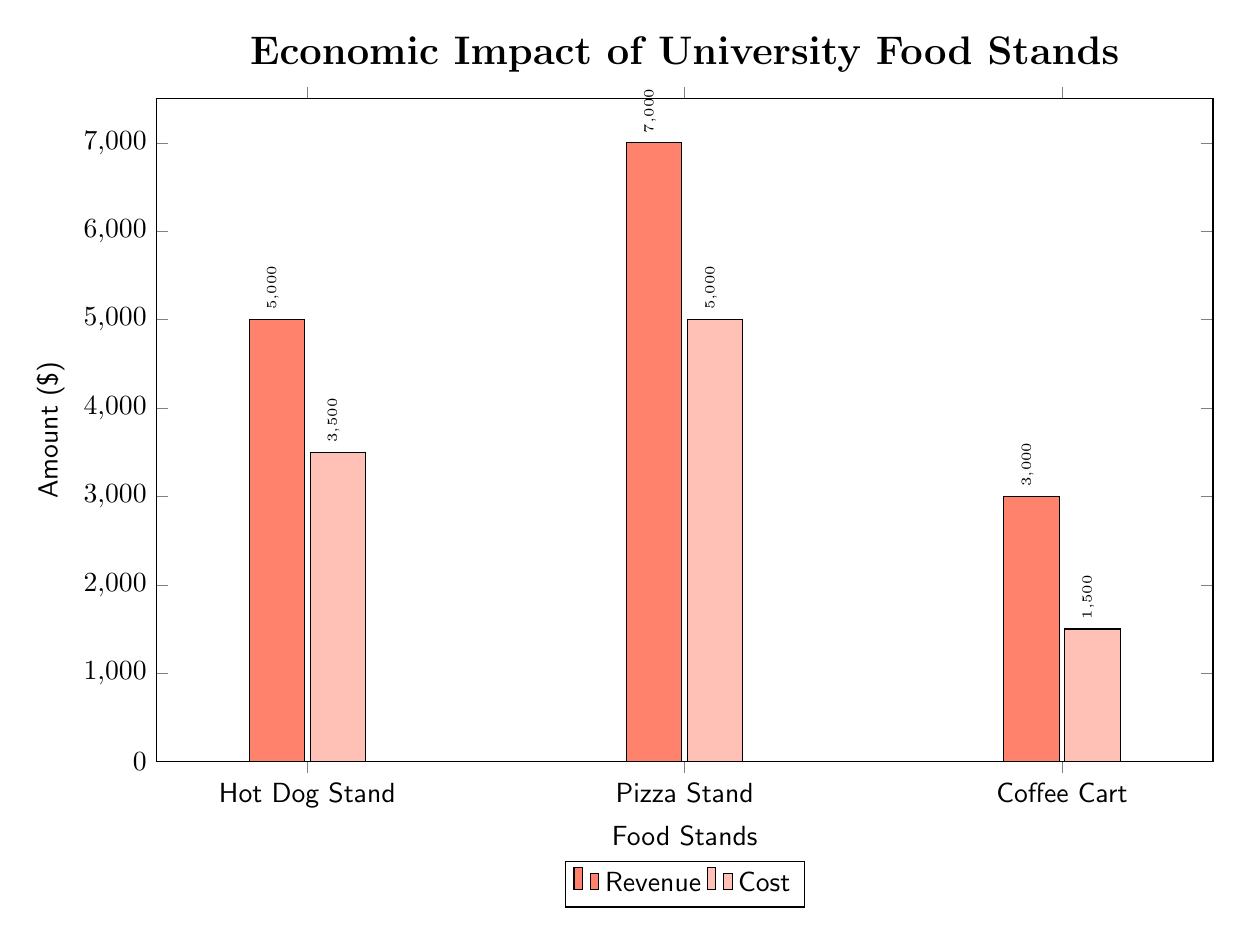What is the revenue for the Hot Dog Stand? The bar representing the revenue for the Hot Dog Stand shows a value of 5000. This can be directly read from the chart where the height of the revenue bar for this stand corresponds to the amount of 5000.
Answer: 5000 What are the costs of the Pizza Stand? The cost for the Pizza Stand is indicated by the lighter-colored bar, which has a height that matches the value of 5000. This is visible in the chart where the lighter bar for Pizza Stand reaches up to 5000.
Answer: 5000 Which food stand generates the highest revenue? By comparing the heights of the revenue bars for all food stands, the Pizza Stand has the highest value at 7000, higher than both the Hot Dog Stand and Coffee Cart. Therefore, the conclusion is drawn from the tallest bar.
Answer: Pizza Stand What is the total revenue for all food stands combined? To find the total revenue, add the individual revenues: 5000 (Hot Dog Stand) + 7000 (Pizza Stand) + 3000 (Coffee Cart) = 15000. This calculation considers all revenue values indicated on the graph.
Answer: 15000 What is the difference between the revenue and cost for the Coffee Cart? The revenue for the Coffee Cart is 3000, while its cost is 1500. The difference is calculated as 3000 - 1500, which equals 1500. This calculation involves subtracting the cost from the revenue for that specific stand.
Answer: 1500 Which food stand has the lowest cost? The Coffee Cart has the lowest cost, with a value of 1500, which is clearly the shortest bar when comparing the costs of all food stands displayed in the chart.
Answer: Coffee Cart What is the overall profit for the Hot Dog Stand? To calculate the profit for the Hot Dog Stand, subtract the cost from the revenue: 5000 (revenue) - 3500 (cost) = 1500. The profit is determined by analyzing the respective bars for this stand and executing the subtraction.
Answer: 1500 How many food stands are represented in the diagram? There are three food stands shown in the diagram: Hot Dog Stand, Pizza Stand, and Coffee Cart. The count can be determined by counting the distinct labels on the x-axis.
Answer: 3 What color represents revenue in the diagram? The color representing revenue is the darker shade of hot dog color, which is interpreted as the filled bars reaching higher values on the chart. This is identified by observing the legend on the diagram that indicates the colors assigned to revenue and cost.
Answer: hot dog color 